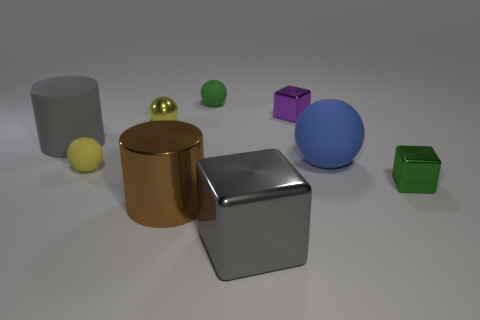There is a block that is the same color as the rubber cylinder; what size is it?
Provide a short and direct response. Large. There is a large thing that is the same color as the large metal cube; what is its shape?
Provide a short and direct response. Cylinder. There is a metallic cylinder; is its color the same as the big matte thing that is in front of the big rubber cylinder?
Give a very brief answer. No. Is the number of large blue objects behind the shiny ball less than the number of big gray shiny balls?
Your answer should be very brief. No. What is the sphere right of the gray metallic cube made of?
Your answer should be compact. Rubber. What number of other objects are the same size as the gray rubber thing?
Give a very brief answer. 3. Do the gray cube and the matte thing behind the tiny yellow shiny ball have the same size?
Ensure brevity in your answer.  No. There is a gray thing to the left of the green object that is on the left side of the large rubber object that is to the right of the gray shiny object; what shape is it?
Give a very brief answer. Cylinder. Are there fewer gray metallic objects than small cubes?
Your response must be concise. Yes. Are there any large blue rubber things on the left side of the shiny cylinder?
Make the answer very short. No. 